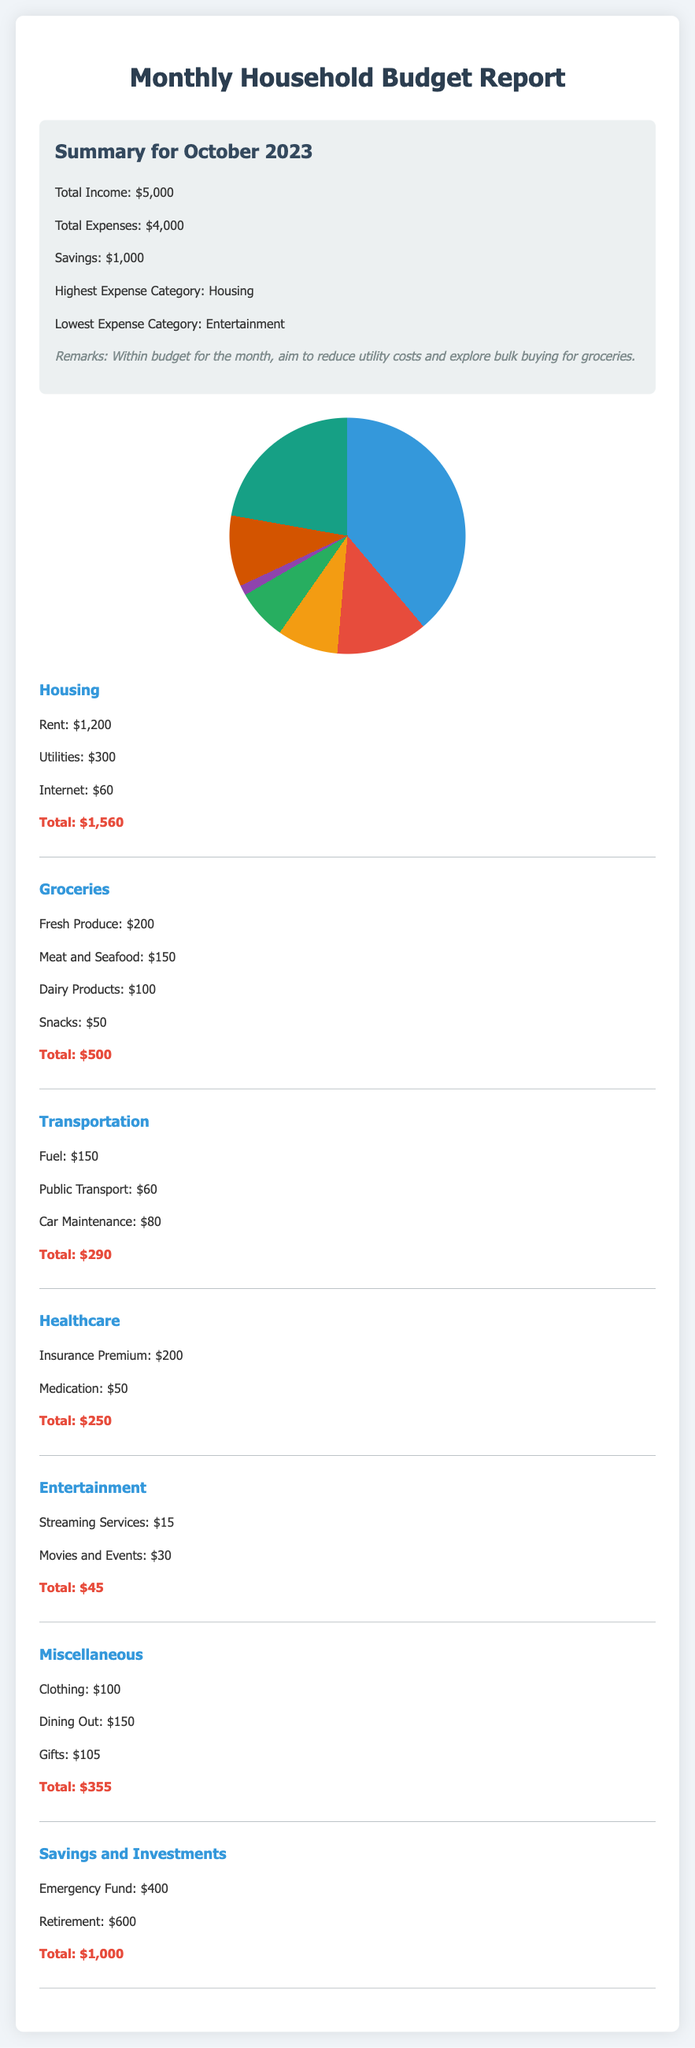What is the total income? The total income is directly stated in the summary section of the document.
Answer: $5,000 What is the highest expense category? The summary section mentions the highest expense category as it compares categories.
Answer: Housing How much was spent on groceries? The total for groceries is calculated from individual grocery expenses listed.
Answer: $500 What is the total amount saved? The savings amount is explicitly mentioned in the summary section.
Answer: $1,000 What are the expenses for entertainment? The document lists the individual entertainment expenses, totaling them for clarity.
Answer: $45 What percentage of the total income is allocated to housing? Housing expenses are compared to total income to derive this percentage.
Answer: 31.2% Which category had the lowest total expense? This requires searching the individual totals and comparing them to find the lowest.
Answer: Entertainment How much was spent on healthcare? The total healthcare expense is summarized from individual healthcare costs detailed in the document.
Answer: $250 What is the total for savings and investments? This total comes from the sum of individual savings and investment entries.
Answer: $1,000 